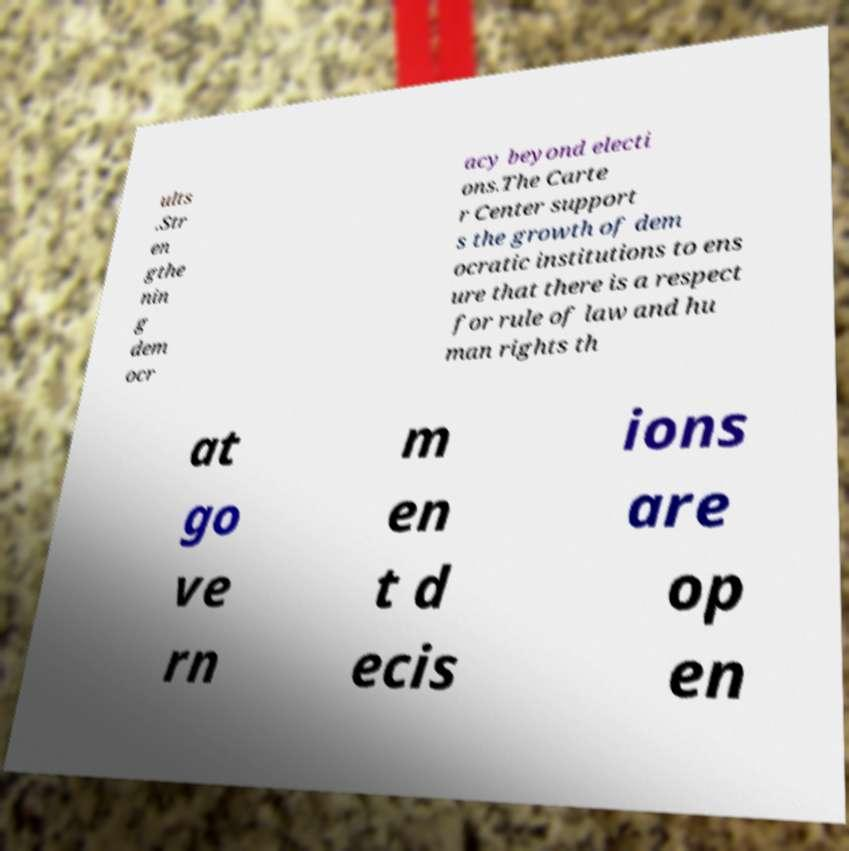Can you read and provide the text displayed in the image?This photo seems to have some interesting text. Can you extract and type it out for me? ults .Str en gthe nin g dem ocr acy beyond electi ons.The Carte r Center support s the growth of dem ocratic institutions to ens ure that there is a respect for rule of law and hu man rights th at go ve rn m en t d ecis ions are op en 